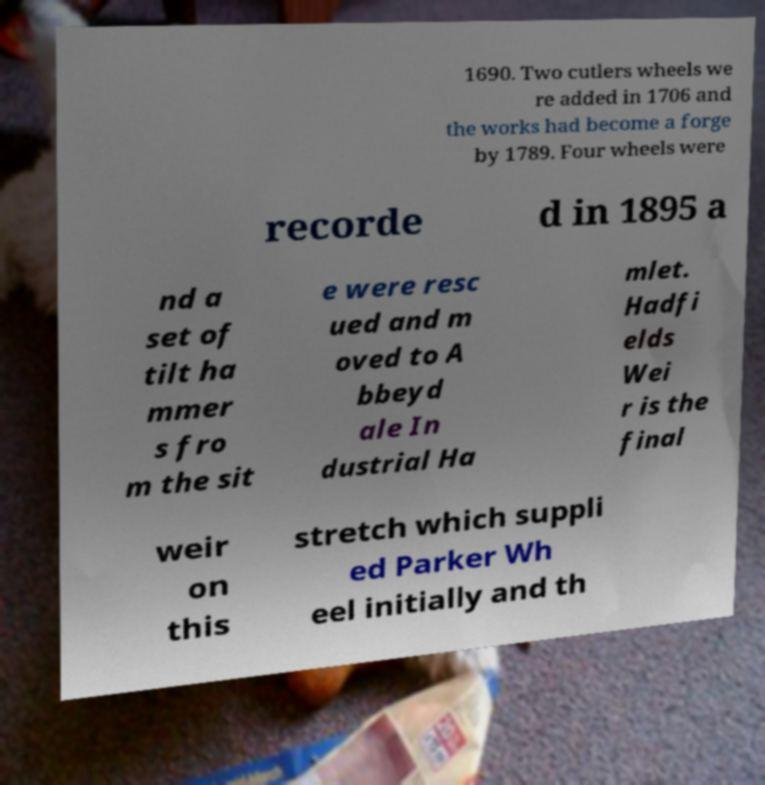Please identify and transcribe the text found in this image. 1690. Two cutlers wheels we re added in 1706 and the works had become a forge by 1789. Four wheels were recorde d in 1895 a nd a set of tilt ha mmer s fro m the sit e were resc ued and m oved to A bbeyd ale In dustrial Ha mlet. Hadfi elds Wei r is the final weir on this stretch which suppli ed Parker Wh eel initially and th 